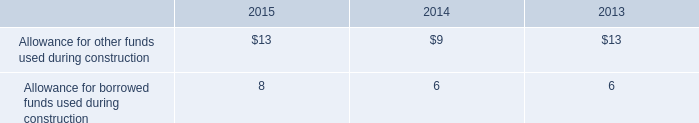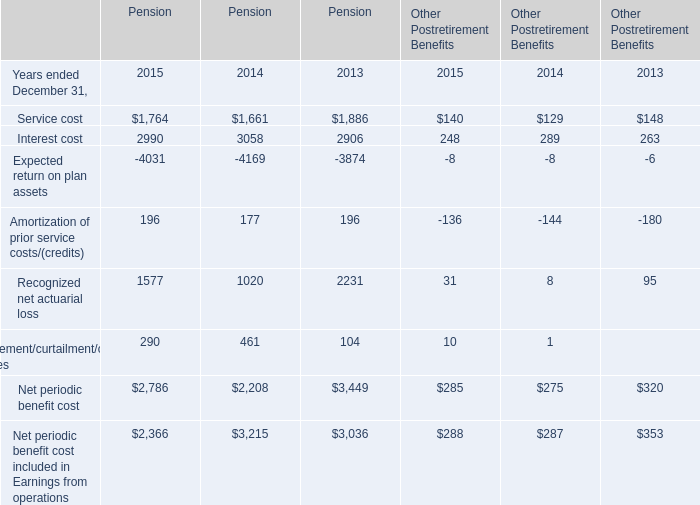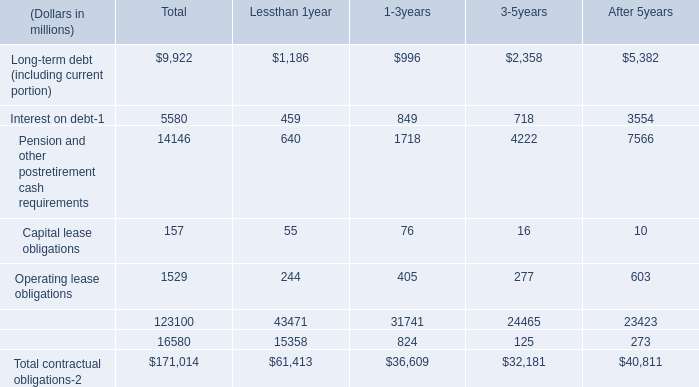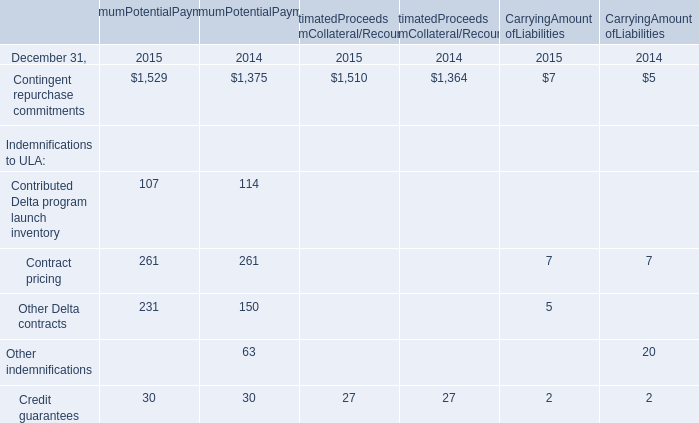What's the sum of Recognized net actuarial loss of Pension 2013, Contingent repurchase commitments of EstimatedProceeds fromCollateral/Recourse 2014, and Interest cost of Pension 2014 ? 
Computations: ((2231.0 + 1364.0) + 3058.0)
Answer: 6653.0. 